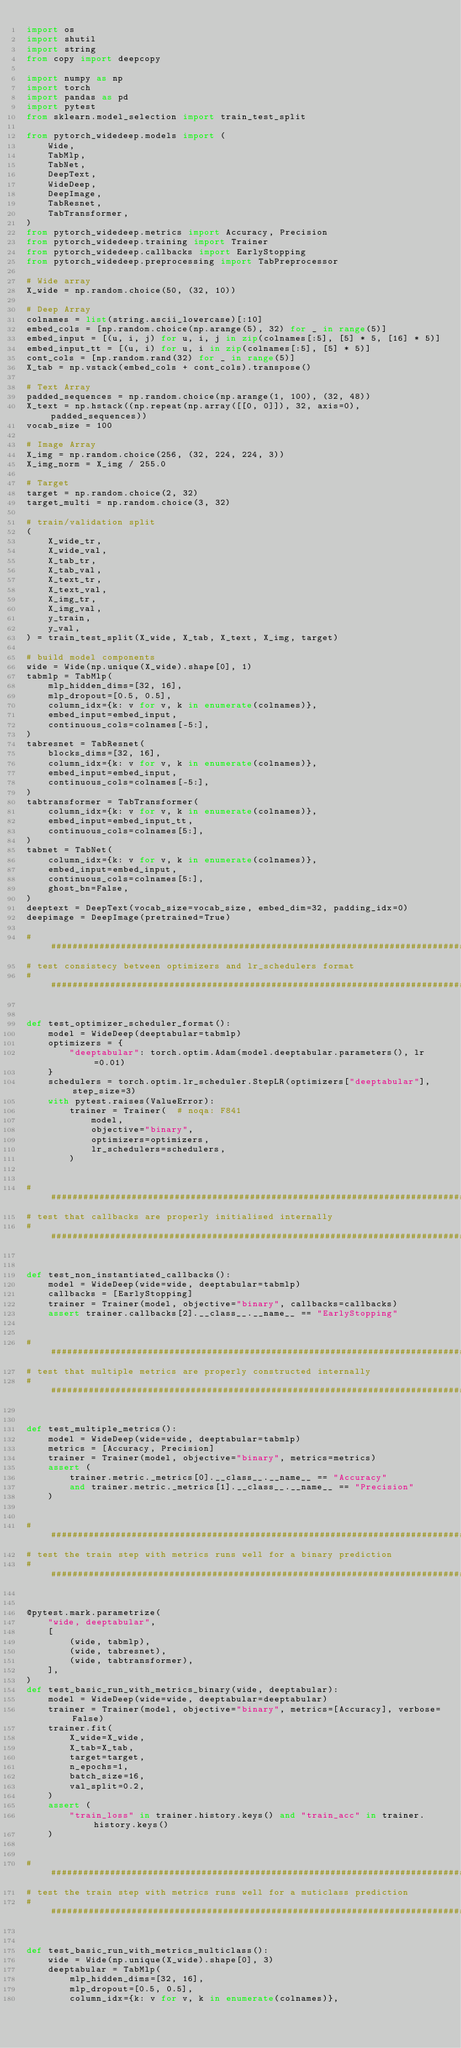Convert code to text. <code><loc_0><loc_0><loc_500><loc_500><_Python_>import os
import shutil
import string
from copy import deepcopy

import numpy as np
import torch
import pandas as pd
import pytest
from sklearn.model_selection import train_test_split

from pytorch_widedeep.models import (
    Wide,
    TabMlp,
    TabNet,
    DeepText,
    WideDeep,
    DeepImage,
    TabResnet,
    TabTransformer,
)
from pytorch_widedeep.metrics import Accuracy, Precision
from pytorch_widedeep.training import Trainer
from pytorch_widedeep.callbacks import EarlyStopping
from pytorch_widedeep.preprocessing import TabPreprocessor

# Wide array
X_wide = np.random.choice(50, (32, 10))

# Deep Array
colnames = list(string.ascii_lowercase)[:10]
embed_cols = [np.random.choice(np.arange(5), 32) for _ in range(5)]
embed_input = [(u, i, j) for u, i, j in zip(colnames[:5], [5] * 5, [16] * 5)]
embed_input_tt = [(u, i) for u, i in zip(colnames[:5], [5] * 5)]
cont_cols = [np.random.rand(32) for _ in range(5)]
X_tab = np.vstack(embed_cols + cont_cols).transpose()

# Text Array
padded_sequences = np.random.choice(np.arange(1, 100), (32, 48))
X_text = np.hstack((np.repeat(np.array([[0, 0]]), 32, axis=0), padded_sequences))
vocab_size = 100

# Image Array
X_img = np.random.choice(256, (32, 224, 224, 3))
X_img_norm = X_img / 255.0

# Target
target = np.random.choice(2, 32)
target_multi = np.random.choice(3, 32)

# train/validation split
(
    X_wide_tr,
    X_wide_val,
    X_tab_tr,
    X_tab_val,
    X_text_tr,
    X_text_val,
    X_img_tr,
    X_img_val,
    y_train,
    y_val,
) = train_test_split(X_wide, X_tab, X_text, X_img, target)

# build model components
wide = Wide(np.unique(X_wide).shape[0], 1)
tabmlp = TabMlp(
    mlp_hidden_dims=[32, 16],
    mlp_dropout=[0.5, 0.5],
    column_idx={k: v for v, k in enumerate(colnames)},
    embed_input=embed_input,
    continuous_cols=colnames[-5:],
)
tabresnet = TabResnet(
    blocks_dims=[32, 16],
    column_idx={k: v for v, k in enumerate(colnames)},
    embed_input=embed_input,
    continuous_cols=colnames[-5:],
)
tabtransformer = TabTransformer(
    column_idx={k: v for v, k in enumerate(colnames)},
    embed_input=embed_input_tt,
    continuous_cols=colnames[5:],
)
tabnet = TabNet(
    column_idx={k: v for v, k in enumerate(colnames)},
    embed_input=embed_input,
    continuous_cols=colnames[5:],
    ghost_bn=False,
)
deeptext = DeepText(vocab_size=vocab_size, embed_dim=32, padding_idx=0)
deepimage = DeepImage(pretrained=True)

###############################################################################
# test consistecy between optimizers and lr_schedulers format
###############################################################################


def test_optimizer_scheduler_format():
    model = WideDeep(deeptabular=tabmlp)
    optimizers = {
        "deeptabular": torch.optim.Adam(model.deeptabular.parameters(), lr=0.01)
    }
    schedulers = torch.optim.lr_scheduler.StepLR(optimizers["deeptabular"], step_size=3)
    with pytest.raises(ValueError):
        trainer = Trainer(  # noqa: F841
            model,
            objective="binary",
            optimizers=optimizers,
            lr_schedulers=schedulers,
        )


###############################################################################
# test that callbacks are properly initialised internally
###############################################################################


def test_non_instantiated_callbacks():
    model = WideDeep(wide=wide, deeptabular=tabmlp)
    callbacks = [EarlyStopping]
    trainer = Trainer(model, objective="binary", callbacks=callbacks)
    assert trainer.callbacks[2].__class__.__name__ == "EarlyStopping"


###############################################################################
# test that multiple metrics are properly constructed internally
###############################################################################


def test_multiple_metrics():
    model = WideDeep(wide=wide, deeptabular=tabmlp)
    metrics = [Accuracy, Precision]
    trainer = Trainer(model, objective="binary", metrics=metrics)
    assert (
        trainer.metric._metrics[0].__class__.__name__ == "Accuracy"
        and trainer.metric._metrics[1].__class__.__name__ == "Precision"
    )


###############################################################################
# test the train step with metrics runs well for a binary prediction
###############################################################################


@pytest.mark.parametrize(
    "wide, deeptabular",
    [
        (wide, tabmlp),
        (wide, tabresnet),
        (wide, tabtransformer),
    ],
)
def test_basic_run_with_metrics_binary(wide, deeptabular):
    model = WideDeep(wide=wide, deeptabular=deeptabular)
    trainer = Trainer(model, objective="binary", metrics=[Accuracy], verbose=False)
    trainer.fit(
        X_wide=X_wide,
        X_tab=X_tab,
        target=target,
        n_epochs=1,
        batch_size=16,
        val_split=0.2,
    )
    assert (
        "train_loss" in trainer.history.keys() and "train_acc" in trainer.history.keys()
    )


###############################################################################
# test the train step with metrics runs well for a muticlass prediction
###############################################################################


def test_basic_run_with_metrics_multiclass():
    wide = Wide(np.unique(X_wide).shape[0], 3)
    deeptabular = TabMlp(
        mlp_hidden_dims=[32, 16],
        mlp_dropout=[0.5, 0.5],
        column_idx={k: v for v, k in enumerate(colnames)},</code> 